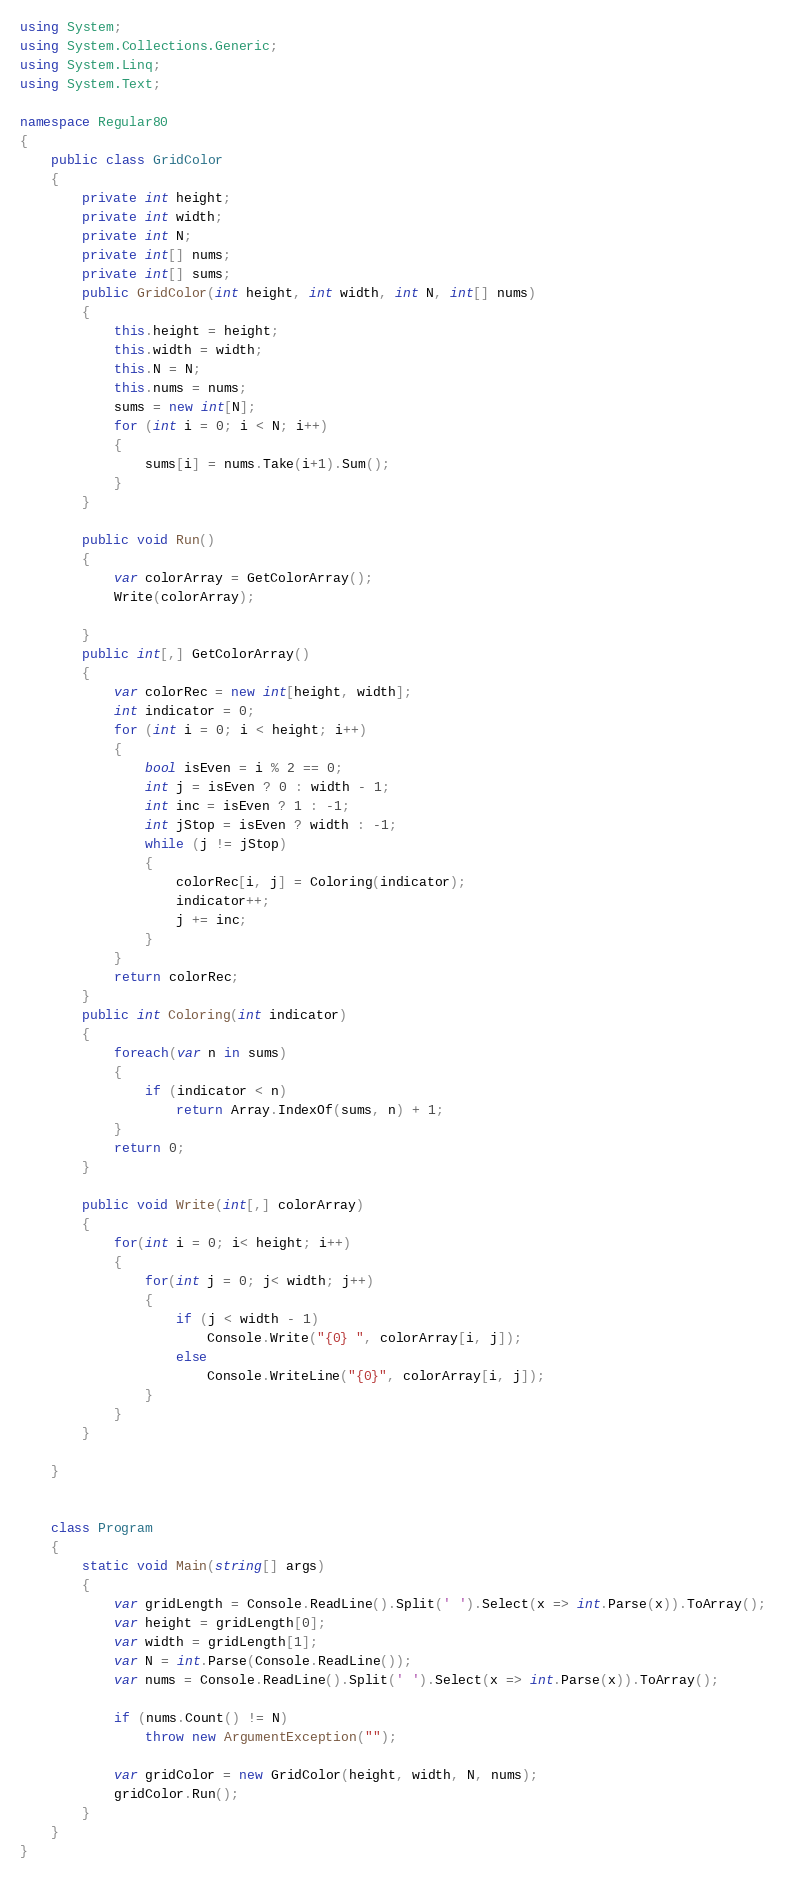Convert code to text. <code><loc_0><loc_0><loc_500><loc_500><_C#_>using System;
using System.Collections.Generic;
using System.Linq;
using System.Text;

namespace Regular80
{
    public class GridColor
    {
        private int height;
        private int width;
        private int N;
        private int[] nums;
        private int[] sums;
        public GridColor(int height, int width, int N, int[] nums)
        {
            this.height = height;
            this.width = width;
            this.N = N;
            this.nums = nums;
            sums = new int[N];
            for (int i = 0; i < N; i++)
            {
                sums[i] = nums.Take(i+1).Sum();
            }
        }

        public void Run()
        {
            var colorArray = GetColorArray();
            Write(colorArray);

        }
        public int[,] GetColorArray()
        {
            var colorRec = new int[height, width];
            int indicator = 0;
            for (int i = 0; i < height; i++)
            {
                bool isEven = i % 2 == 0;
                int j = isEven ? 0 : width - 1;
                int inc = isEven ? 1 : -1;
                int jStop = isEven ? width : -1;
                while (j != jStop)
                {
                    colorRec[i, j] = Coloring(indicator);
                    indicator++;
                    j += inc;
                }
            }
            return colorRec;
        }
        public int Coloring(int indicator)
        {
            foreach(var n in sums)
            {
                if (indicator < n)
                    return Array.IndexOf(sums, n) + 1;
            }
            return 0;
        }

        public void Write(int[,] colorArray)
        {
            for(int i = 0; i< height; i++)
            {
                for(int j = 0; j< width; j++)
                {
                    if (j < width - 1)
                        Console.Write("{0} ", colorArray[i, j]);
                    else
                        Console.WriteLine("{0}", colorArray[i, j]);
                }
            }
        }

    }


    class Program
    {
        static void Main(string[] args)
        {
            var gridLength = Console.ReadLine().Split(' ').Select(x => int.Parse(x)).ToArray();
            var height = gridLength[0];
            var width = gridLength[1];
            var N = int.Parse(Console.ReadLine());
            var nums = Console.ReadLine().Split(' ').Select(x => int.Parse(x)).ToArray();

            if (nums.Count() != N)
                throw new ArgumentException("");

            var gridColor = new GridColor(height, width, N, nums);
            gridColor.Run();
        }
    }
}
</code> 